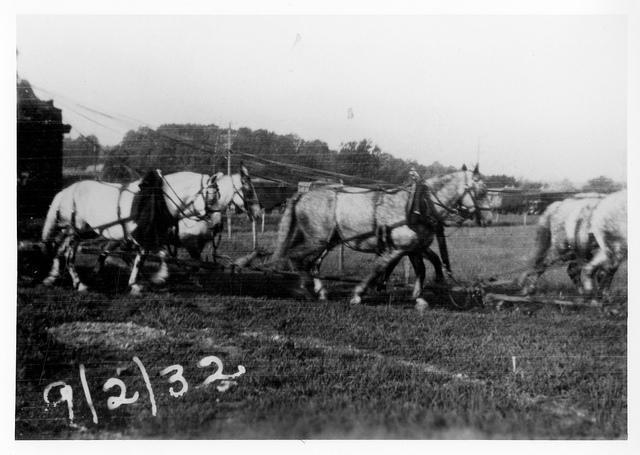How many horses are there?
Give a very brief answer. 4. 